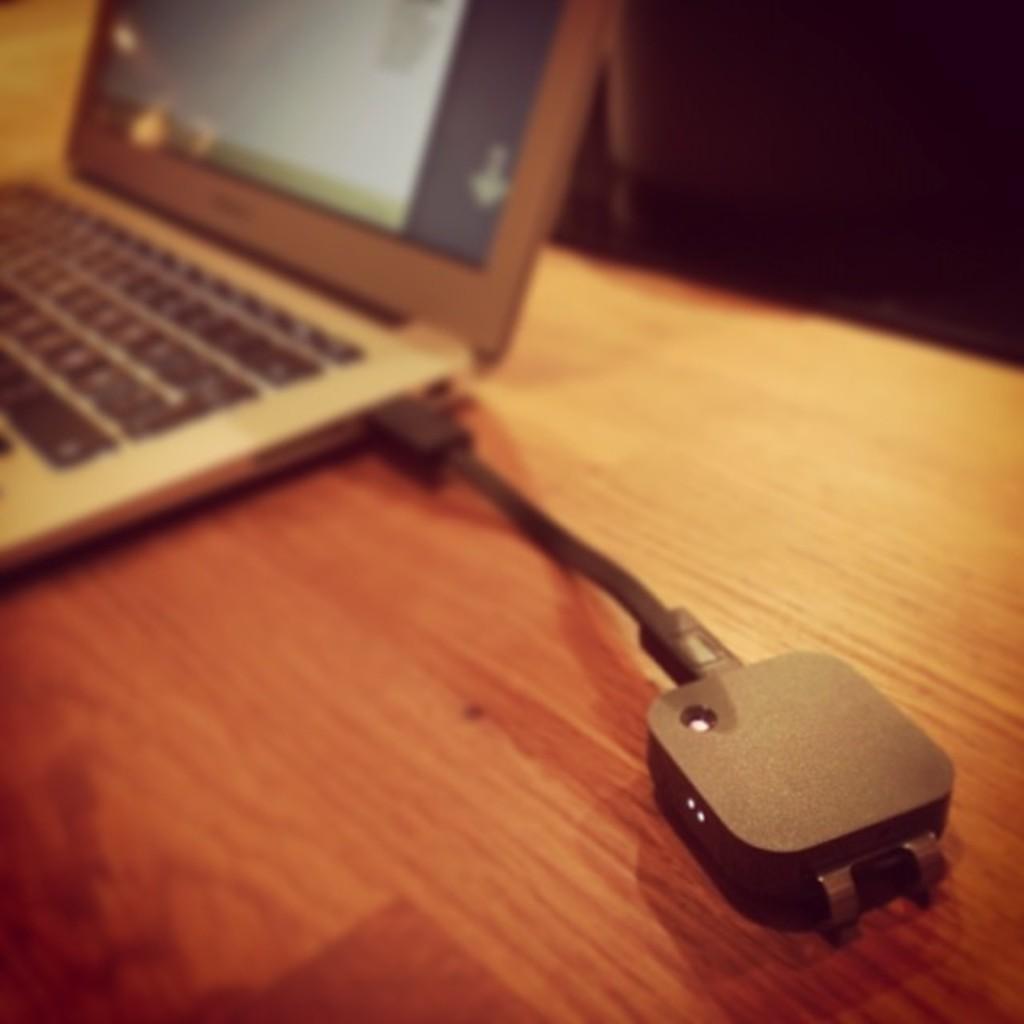Please provide a concise description of this image. In this image we can see laptop and charger adapter which is on the table. 